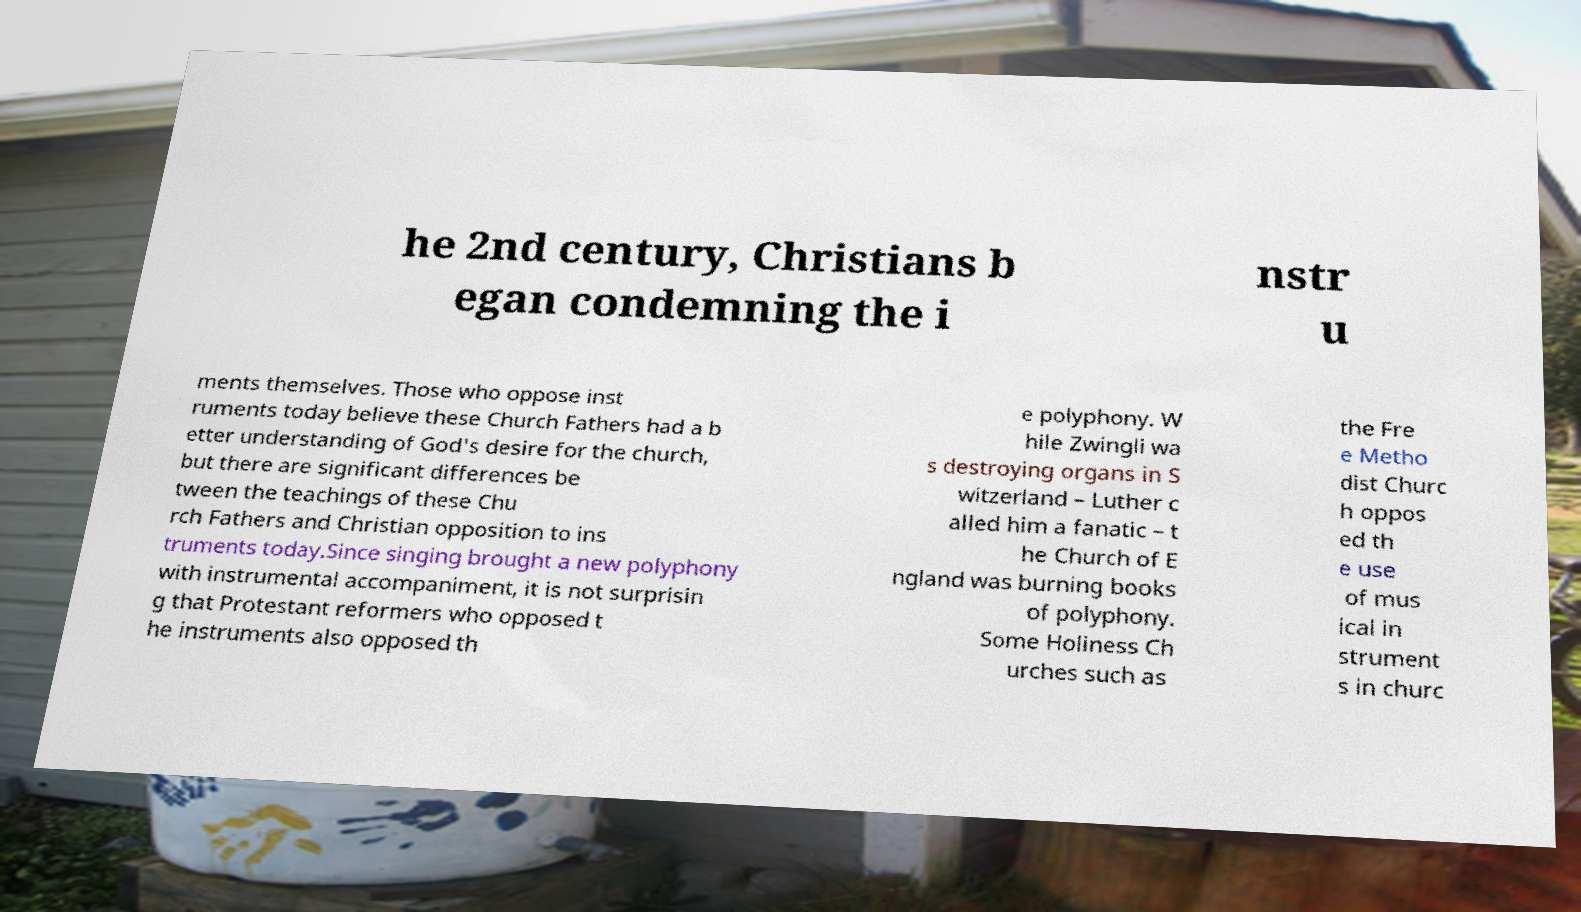Can you accurately transcribe the text from the provided image for me? he 2nd century, Christians b egan condemning the i nstr u ments themselves. Those who oppose inst ruments today believe these Church Fathers had a b etter understanding of God's desire for the church, but there are significant differences be tween the teachings of these Chu rch Fathers and Christian opposition to ins truments today.Since singing brought a new polyphony with instrumental accompaniment, it is not surprisin g that Protestant reformers who opposed t he instruments also opposed th e polyphony. W hile Zwingli wa s destroying organs in S witzerland – Luther c alled him a fanatic – t he Church of E ngland was burning books of polyphony. Some Holiness Ch urches such as the Fre e Metho dist Churc h oppos ed th e use of mus ical in strument s in churc 